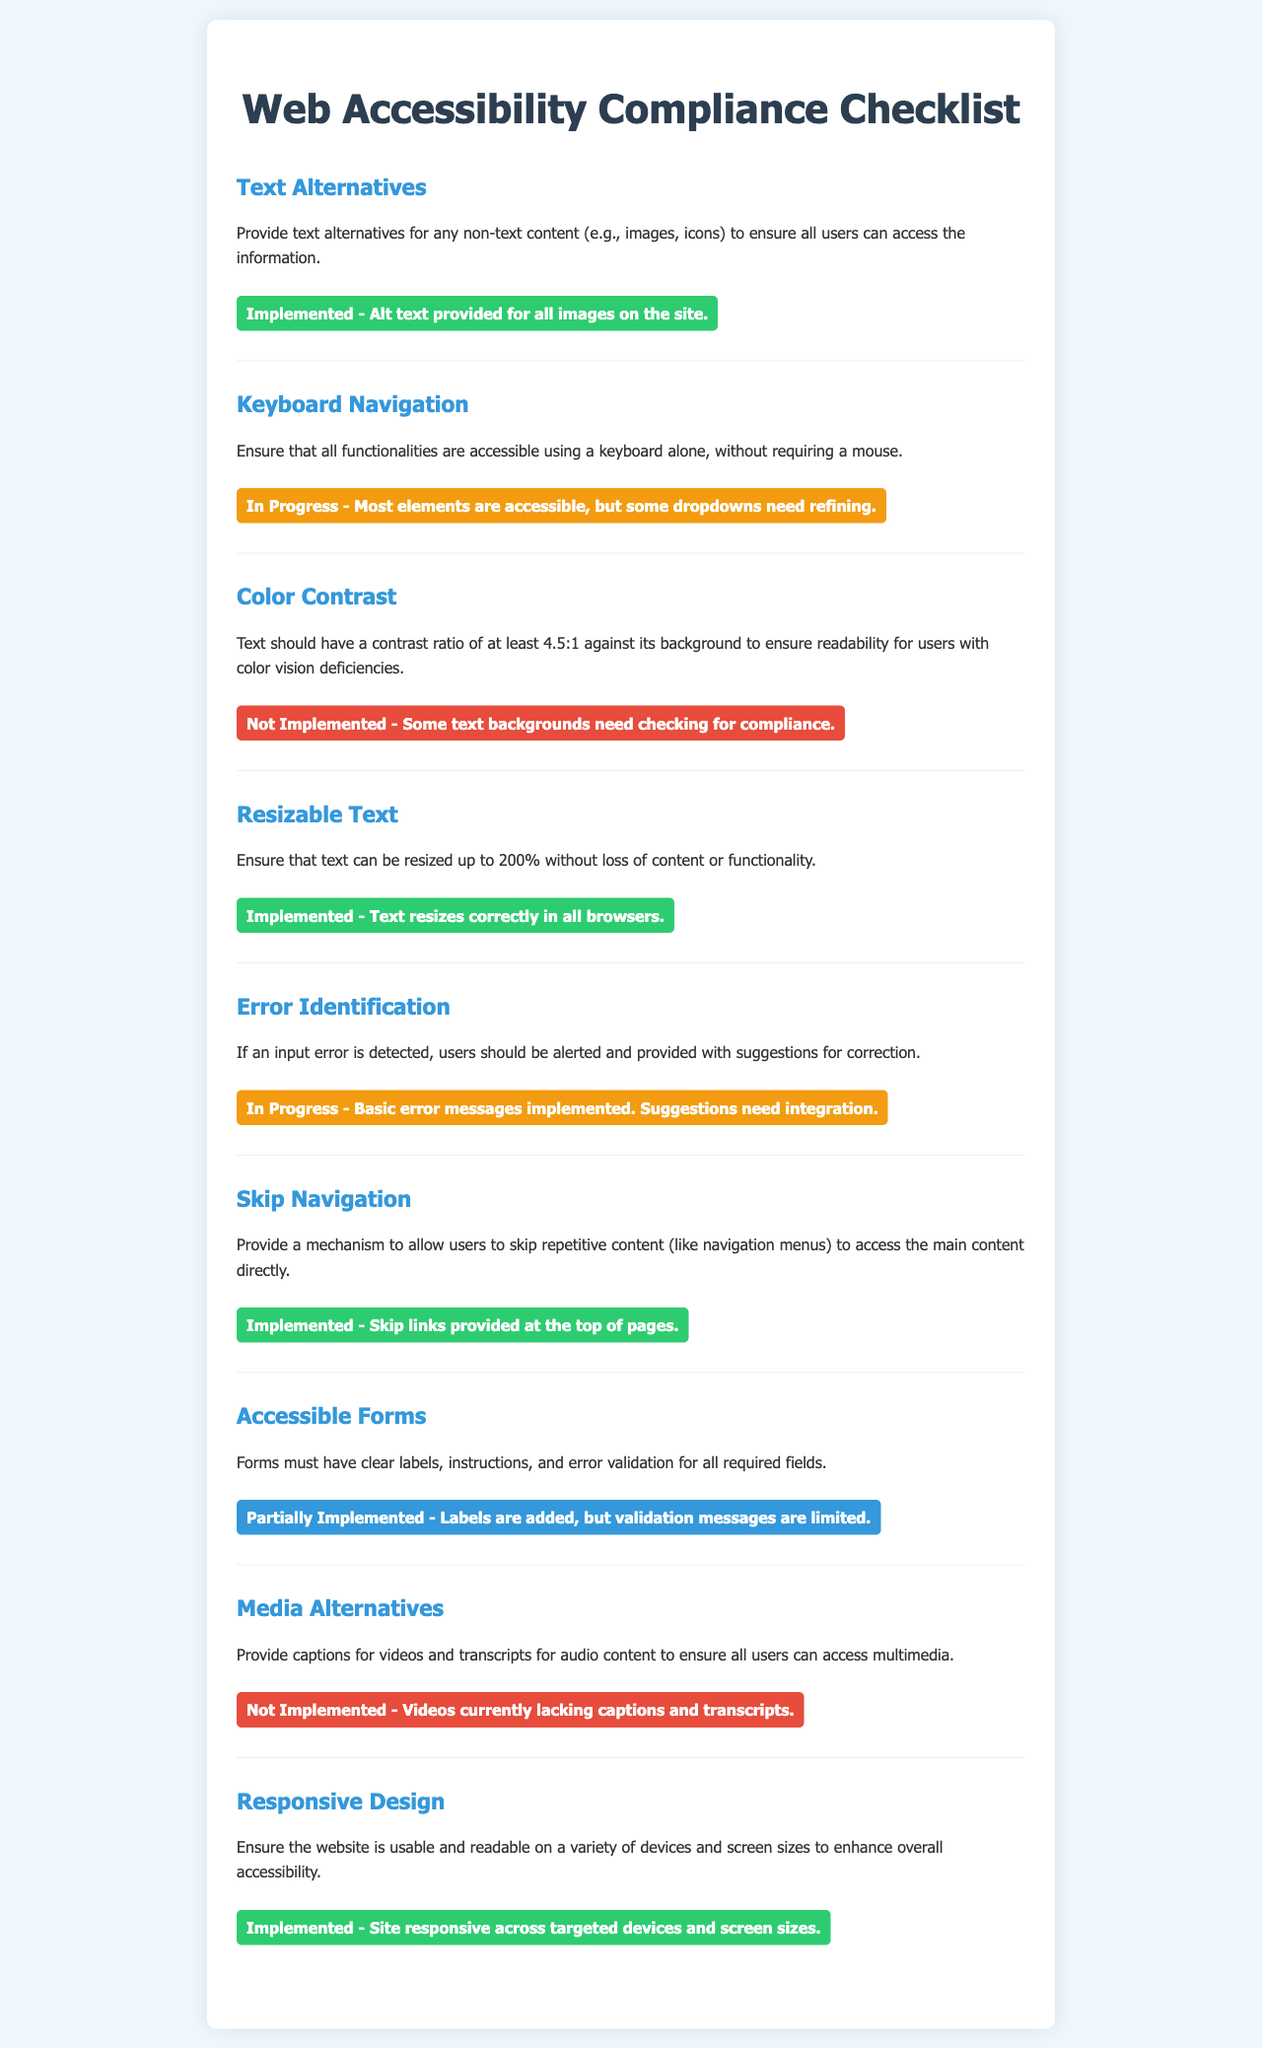What is the status of Text Alternatives? The status indicates whether this particular accessibility criterion has been implemented or not. In the document, it is stated that Alt text is provided for all images.
Answer: Implemented What does the Keyboard Navigation status indicate? This status shows the current progress towards making keyboard navigation accessible. The note specifies that most elements are accessible but requires some refinements.
Answer: In Progress What issue is currently noted with Color Contrast? The document notes that there are certain text backgrounds that require checking for compliance regarding contrast ratios.
Answer: Not Implemented How is Resizable Text currently implemented? The document states that text is resizing correctly across all browsers, indicating successful implementation.
Answer: Implemented What aspect of Accessible Forms is only partially implemented? The document mentions that labels are added to the forms, but validation messages are limited, indicating it is not fully completed.
Answer: Limited validation messages What is provided at the top of pages for Skip Navigation? The document specifies mechanisms provided so that users can bypass repetitious navigation content, allowing direct access to main content.
Answer: Skip links What is the current status of Media Alternatives? The document highlights the absence of captions for videos and transcripts for audio content, indicating that this accessibility need is unfulfilled.
Answer: Not Implemented How has the Responsive Design been characterized? The site is addressed as being responsive across various devices and screen sizes, ensuring usability and readability.
Answer: Implemented 